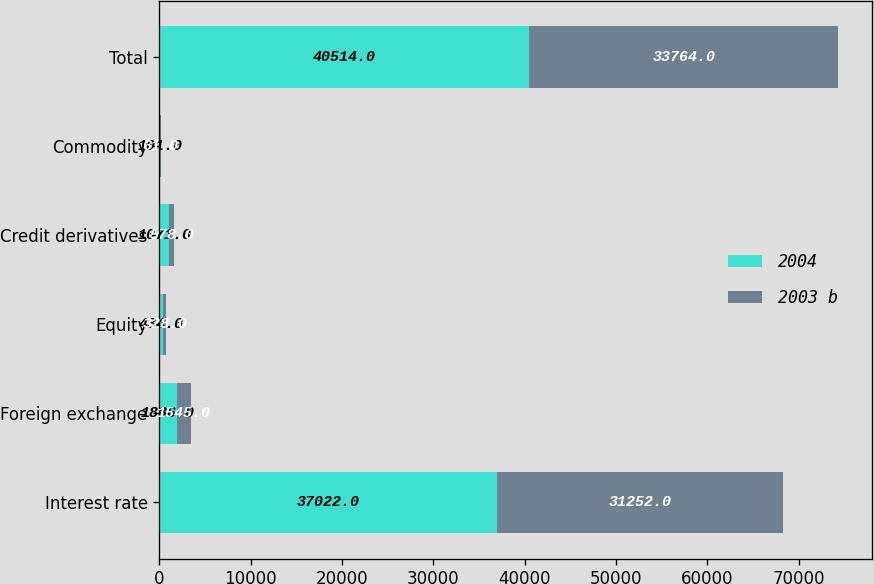<chart> <loc_0><loc_0><loc_500><loc_500><stacked_bar_chart><ecel><fcel>Interest rate<fcel>Foreign exchange<fcel>Equity<fcel>Credit derivatives<fcel>Commodity<fcel>Total<nl><fcel>2004<fcel>37022<fcel>1886<fcel>434<fcel>1071<fcel>101<fcel>40514<nl><fcel>2003 b<fcel>31252<fcel>1545<fcel>328<fcel>578<fcel>61<fcel>33764<nl></chart> 